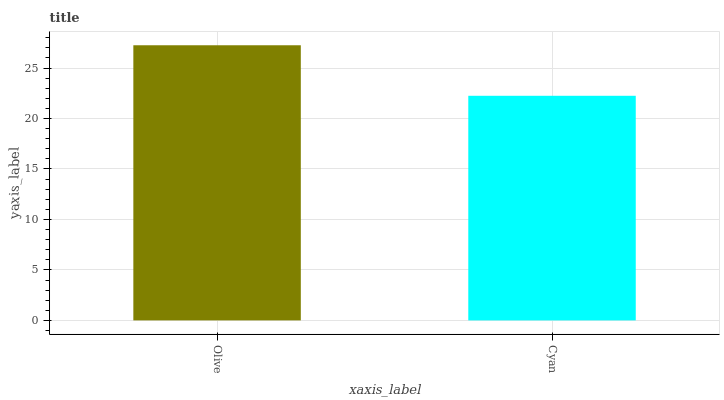Is Cyan the minimum?
Answer yes or no. Yes. Is Olive the maximum?
Answer yes or no. Yes. Is Cyan the maximum?
Answer yes or no. No. Is Olive greater than Cyan?
Answer yes or no. Yes. Is Cyan less than Olive?
Answer yes or no. Yes. Is Cyan greater than Olive?
Answer yes or no. No. Is Olive less than Cyan?
Answer yes or no. No. Is Olive the high median?
Answer yes or no. Yes. Is Cyan the low median?
Answer yes or no. Yes. Is Cyan the high median?
Answer yes or no. No. Is Olive the low median?
Answer yes or no. No. 